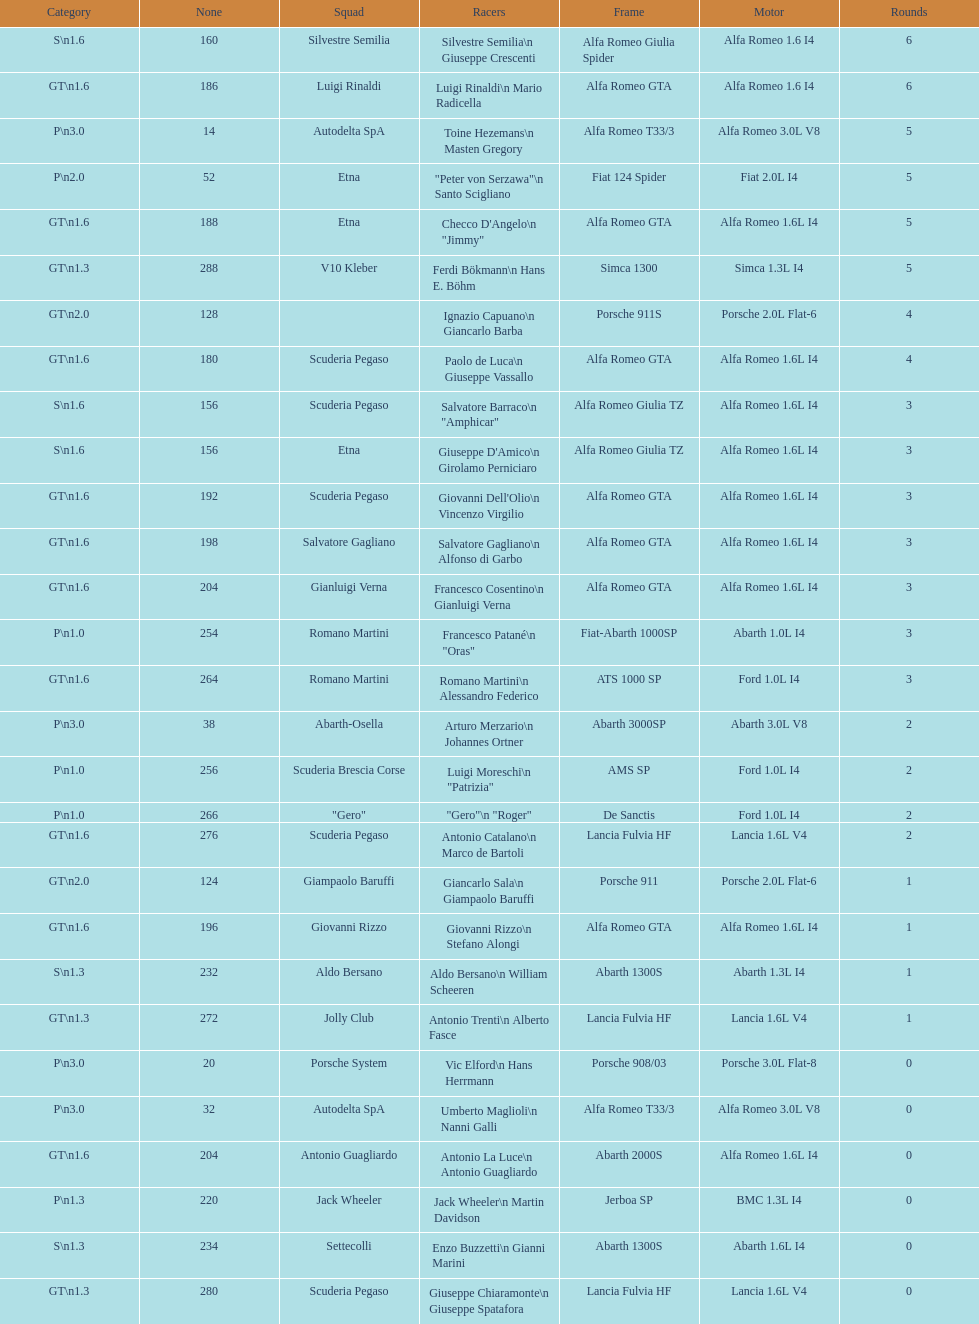What class is under s GT 1.6. 